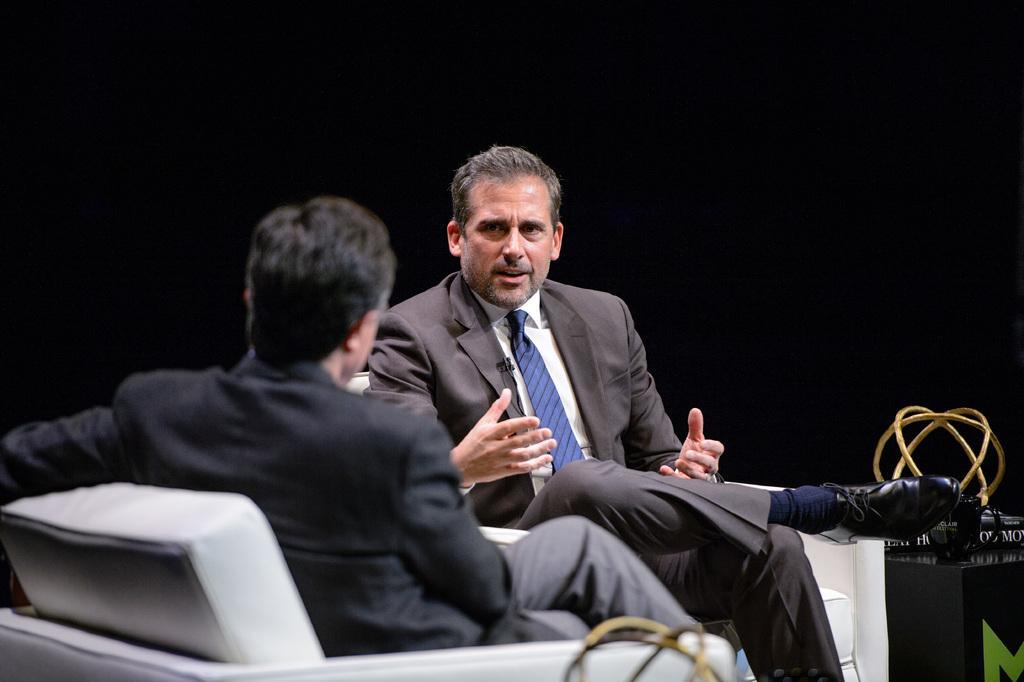Can you describe this image briefly? In this picture we can see two men wore blazers and sitting on chairs and beside to them we can see a stand with books and an object on it and in the background it is dark. 